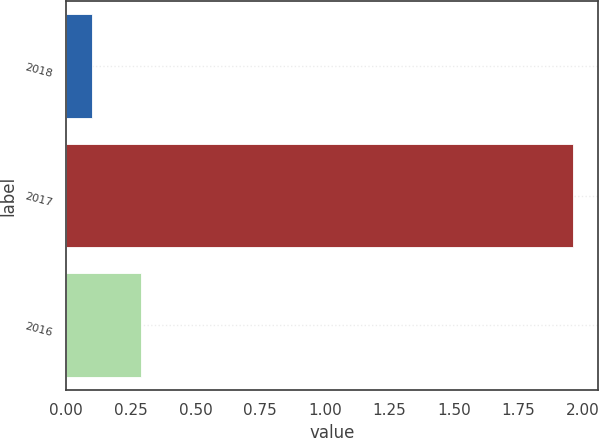<chart> <loc_0><loc_0><loc_500><loc_500><bar_chart><fcel>2018<fcel>2017<fcel>2016<nl><fcel>0.1<fcel>1.96<fcel>0.29<nl></chart> 